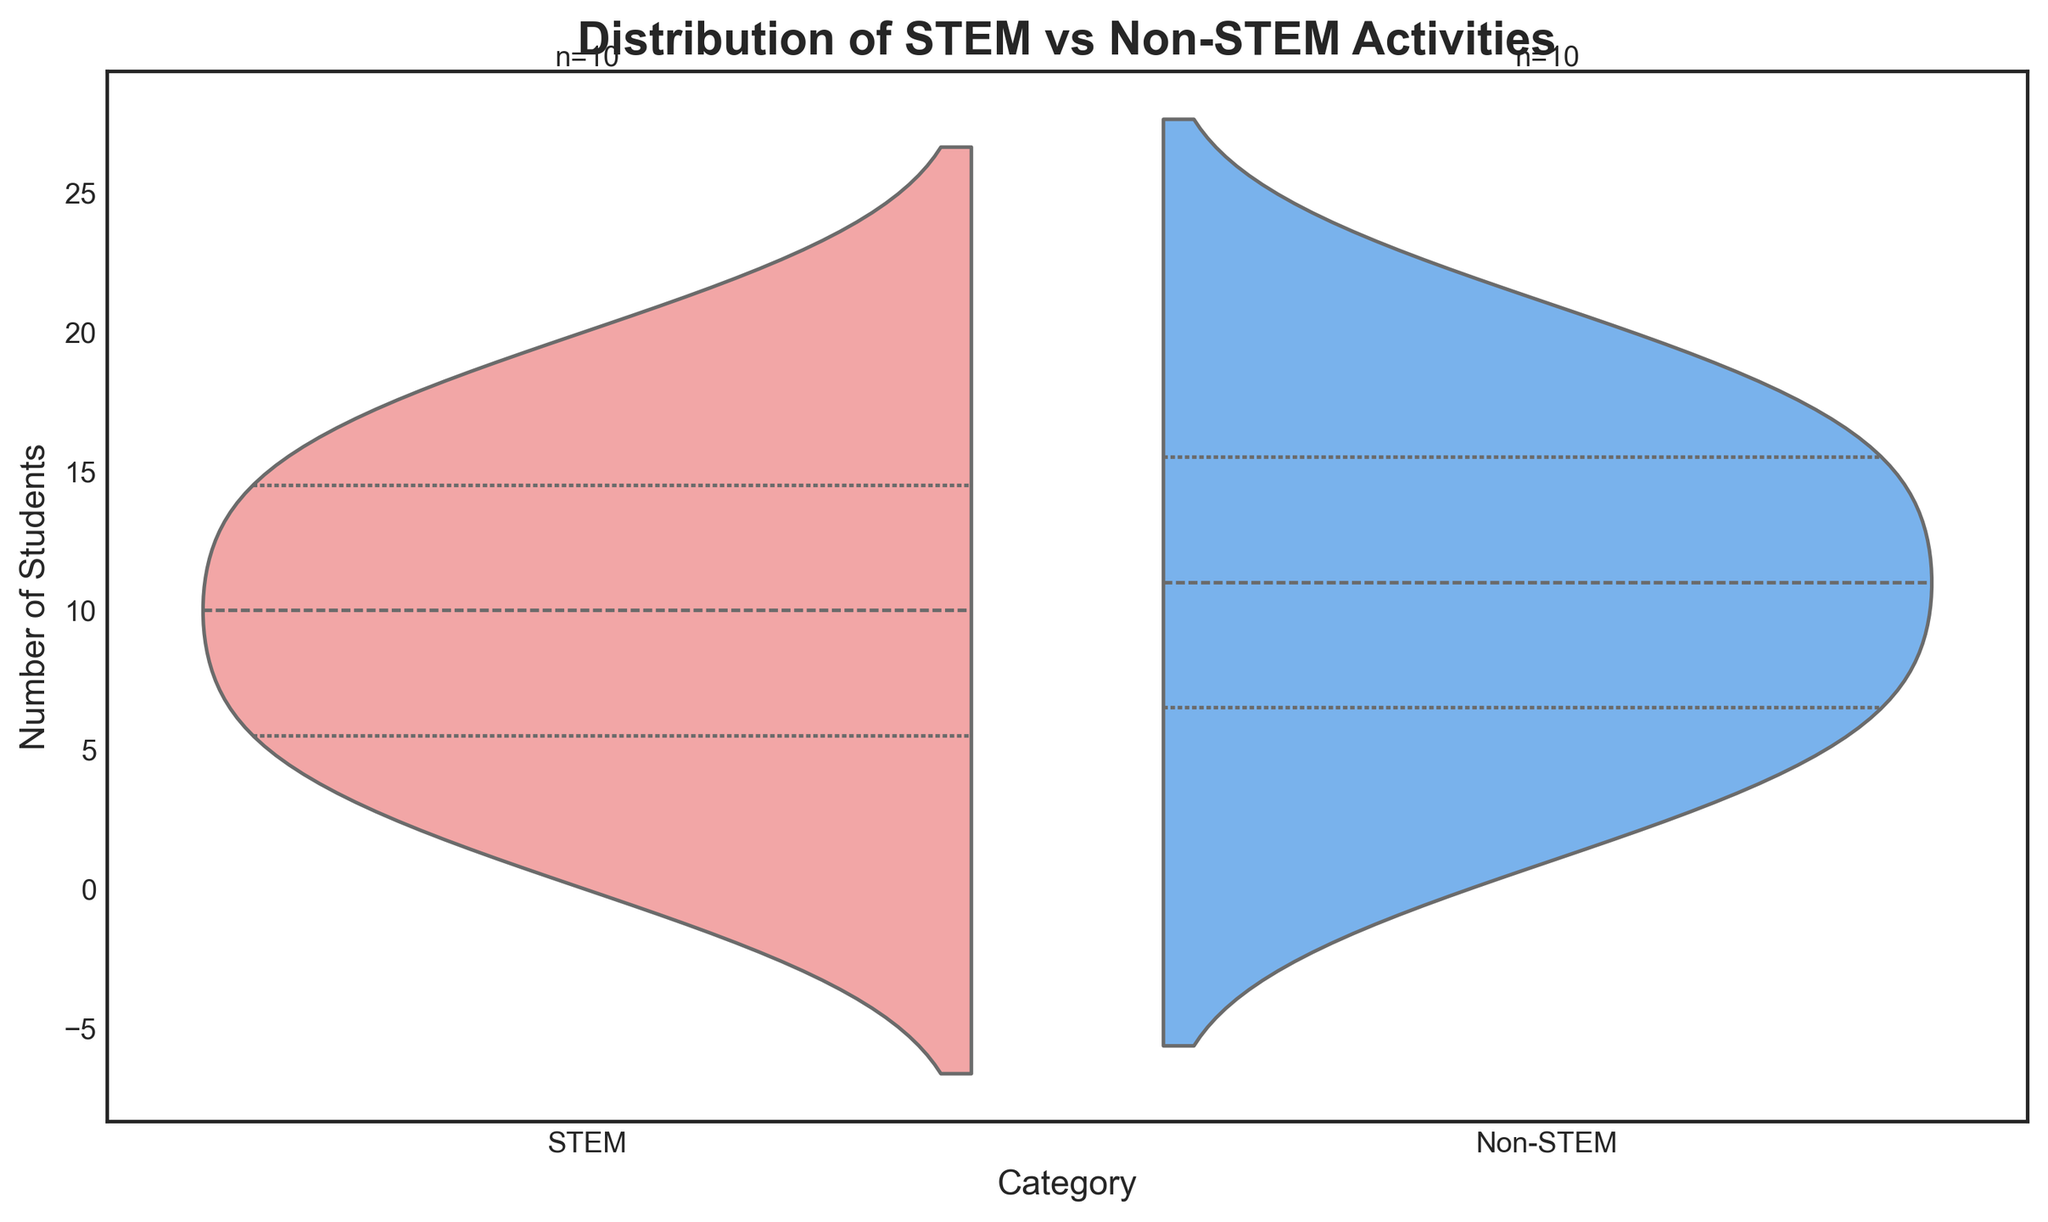What is the title of the chart? The chart title is displayed at the top of the figure.
Answer: Distribution of STEM vs Non-STEM Activities How many students are involved in STEM activities? The number of students in each category is annotated at the top of the plots. The annotation shows "n=" followed by the number. For STEM, it is "n=10".
Answer: 10 How many students are involved in Non-STEM activities? The number of students in each category is labeled at the top of each plot. For Non-STEM, it shows "n=10".
Answer: 10 What is the color used to represent STEM activities? The colors are provided in the legend and the statement of the problem. STEM activities are shown in a pinkish hue.
Answer: Pink What is the color used to represent Non-STEM activities? The problem statement mentions the colors, and you can cross-verify with the legend. Non-STEM activities are displayed in a blue color.
Answer: Blue Which category seems to have more varied distribution of student participation according to the chart? By observing the spread (width) of the violins on each side, STEM activities have a more extensive spread indicating more varied participation.
Answer: STEM Does the number of students in STEM and Non-STEM categories appear equal or unequal? The annotations at the top of each plot indicate counts of both categories; both show "n=10".
Answer: Equal Which category of activities has more participation near the higher range of StudentIDs? Considering the y-axis (StudentID) and the spread of the violin plots, Non-STEM activities seem to have more participation towards higher StudentIDs (15-20).
Answer: Non-STEM What does it mean that the violins are split in this chart? The split violin plot shows two categories side by side for direct comparison. Each half reflects the distribution of students for one category.
Answer: Comparative view What is the highest value on the y-axis? The highest value on the y-axis can be directly read from the axis labels on the left of the figure. The maximum value shown is 20.
Answer: 20 